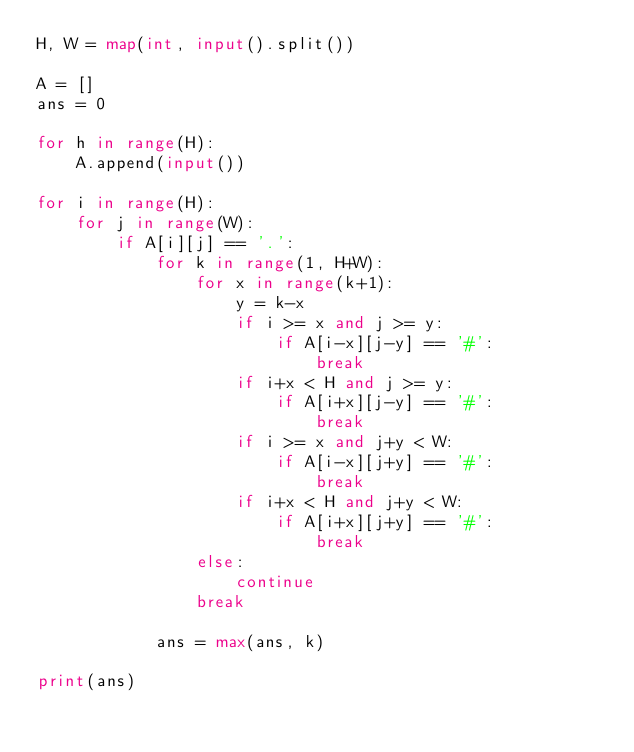Convert code to text. <code><loc_0><loc_0><loc_500><loc_500><_Python_>H, W = map(int, input().split())

A = []
ans = 0

for h in range(H):
    A.append(input())
    
for i in range(H):
    for j in range(W):
        if A[i][j] == '.':
            for k in range(1, H+W):
                for x in range(k+1):
                    y = k-x
                    if i >= x and j >= y:
                        if A[i-x][j-y] == '#':
                            break
                    if i+x < H and j >= y:
                        if A[i+x][j-y] == '#':
                            break                
                    if i >= x and j+y < W:
                        if A[i-x][j+y] == '#':
                            break 
                    if i+x < H and j+y < W:
                        if A[i+x][j+y] == '#':
                            break    
                else:
                    continue
                break
 
            ans = max(ans, k)

print(ans)</code> 